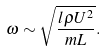Convert formula to latex. <formula><loc_0><loc_0><loc_500><loc_500>\omega \sim \sqrt { \frac { l \rho U ^ { 2 } } { m L } } .</formula> 